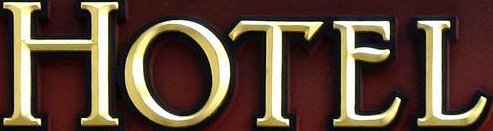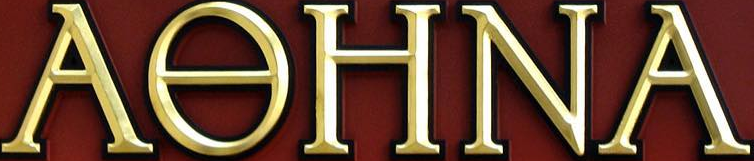What words are shown in these images in order, separated by a semicolon? HOTEL; AƟHNA 